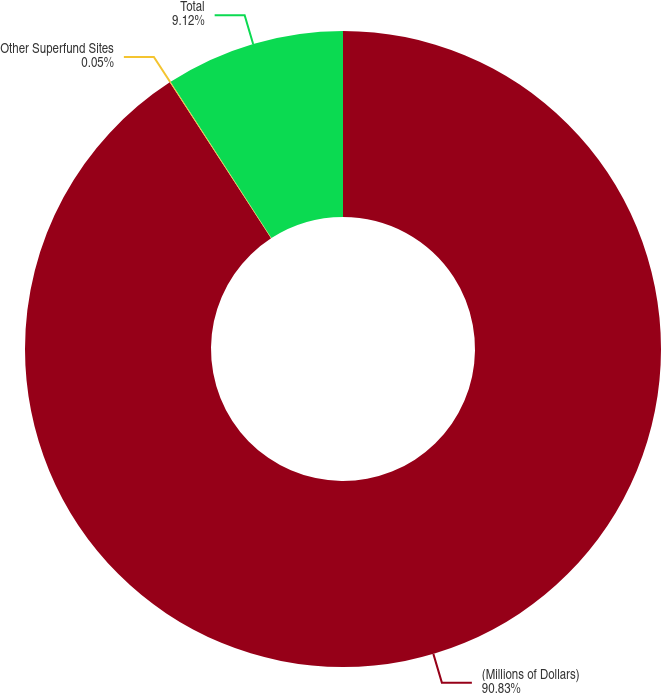Convert chart to OTSL. <chart><loc_0><loc_0><loc_500><loc_500><pie_chart><fcel>(Millions of Dollars)<fcel>Other Superfund Sites<fcel>Total<nl><fcel>90.83%<fcel>0.05%<fcel>9.12%<nl></chart> 